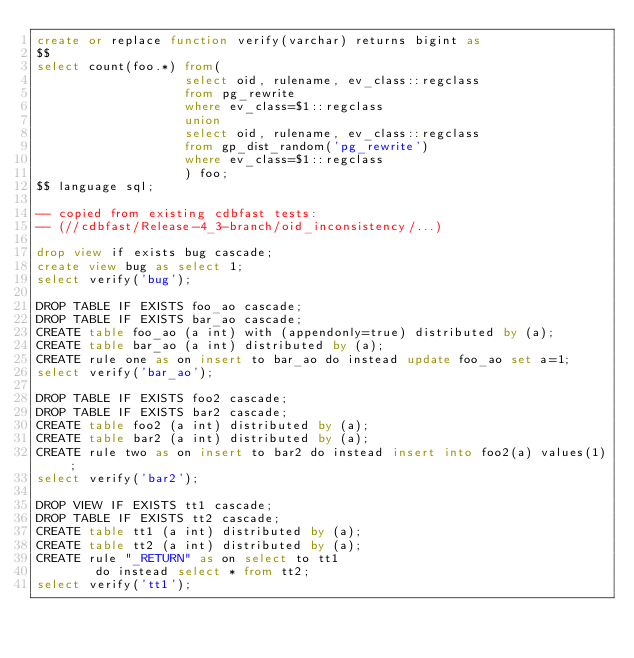<code> <loc_0><loc_0><loc_500><loc_500><_SQL_>create or replace function verify(varchar) returns bigint as
$$
select count(foo.*) from(
                    select oid, rulename, ev_class::regclass
                    from pg_rewrite
                    where ev_class=$1::regclass
                    union
                    select oid, rulename, ev_class::regclass
                    from gp_dist_random('pg_rewrite')
                    where ev_class=$1::regclass
                    ) foo;
$$ language sql;

-- copied from existing cdbfast tests:
-- (//cdbfast/Release-4_3-branch/oid_inconsistency/...)

drop view if exists bug cascade;
create view bug as select 1;
select verify('bug');

DROP TABLE IF EXISTS foo_ao cascade;
DROP TABLE IF EXISTS bar_ao cascade;
CREATE table foo_ao (a int) with (appendonly=true) distributed by (a);
CREATE table bar_ao (a int) distributed by (a);
CREATE rule one as on insert to bar_ao do instead update foo_ao set a=1;
select verify('bar_ao');

DROP TABLE IF EXISTS foo2 cascade;
DROP TABLE IF EXISTS bar2 cascade;
CREATE table foo2 (a int) distributed by (a);
CREATE table bar2 (a int) distributed by (a);
CREATE rule two as on insert to bar2 do instead insert into foo2(a) values(1);
select verify('bar2');

DROP VIEW IF EXISTS tt1 cascade;
DROP TABLE IF EXISTS tt2 cascade;
CREATE table tt1 (a int) distributed by (a);
CREATE table tt2 (a int) distributed by (a);
CREATE rule "_RETURN" as on select to tt1
        do instead select * from tt2;
select verify('tt1');
</code> 